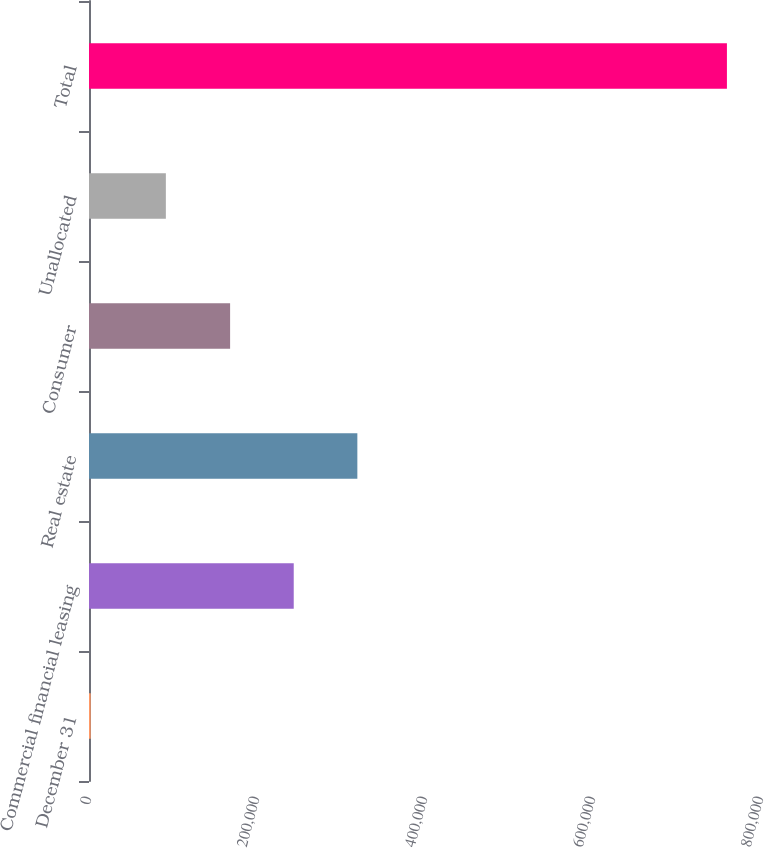<chart> <loc_0><loc_0><loc_500><loc_500><bar_chart><fcel>December 31<fcel>Commercial financial leasing<fcel>Real estate<fcel>Consumer<fcel>Unallocated<fcel>Total<nl><fcel>2007<fcel>243727<fcel>319470<fcel>167984<fcel>91495<fcel>759439<nl></chart> 